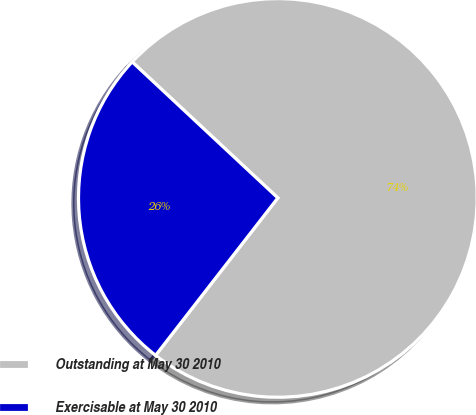Convert chart to OTSL. <chart><loc_0><loc_0><loc_500><loc_500><pie_chart><fcel>Outstanding at May 30 2010<fcel>Exercisable at May 30 2010<nl><fcel>73.55%<fcel>26.45%<nl></chart> 